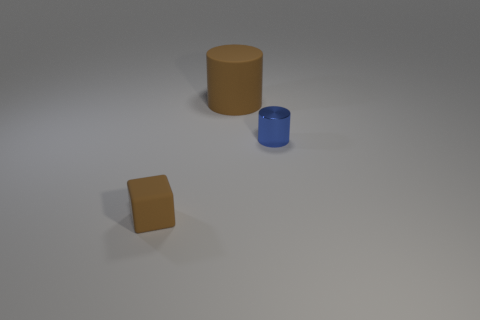Is there a brown rubber object of the same size as the blue shiny thing?
Provide a short and direct response. Yes. Is the number of brown objects that are to the right of the brown cube greater than the number of tiny brown things that are behind the small cylinder?
Offer a very short reply. Yes. Does the large brown cylinder have the same material as the tiny thing on the left side of the large thing?
Ensure brevity in your answer.  Yes. There is a matte object on the left side of the cylinder that is behind the tiny blue object; what number of tiny brown rubber objects are to the right of it?
Give a very brief answer. 0. Is the shape of the large rubber object the same as the small object on the left side of the large matte thing?
Ensure brevity in your answer.  No. There is a object that is right of the small brown matte thing and in front of the big brown cylinder; what is its color?
Your answer should be compact. Blue. There is a small object that is right of the brown object on the right side of the brown object in front of the big cylinder; what is it made of?
Provide a succinct answer. Metal. What is the material of the small brown object?
Your response must be concise. Rubber. There is another metallic object that is the same shape as the big object; what is its size?
Your answer should be very brief. Small. Is the tiny cylinder the same color as the rubber cylinder?
Offer a very short reply. No. 